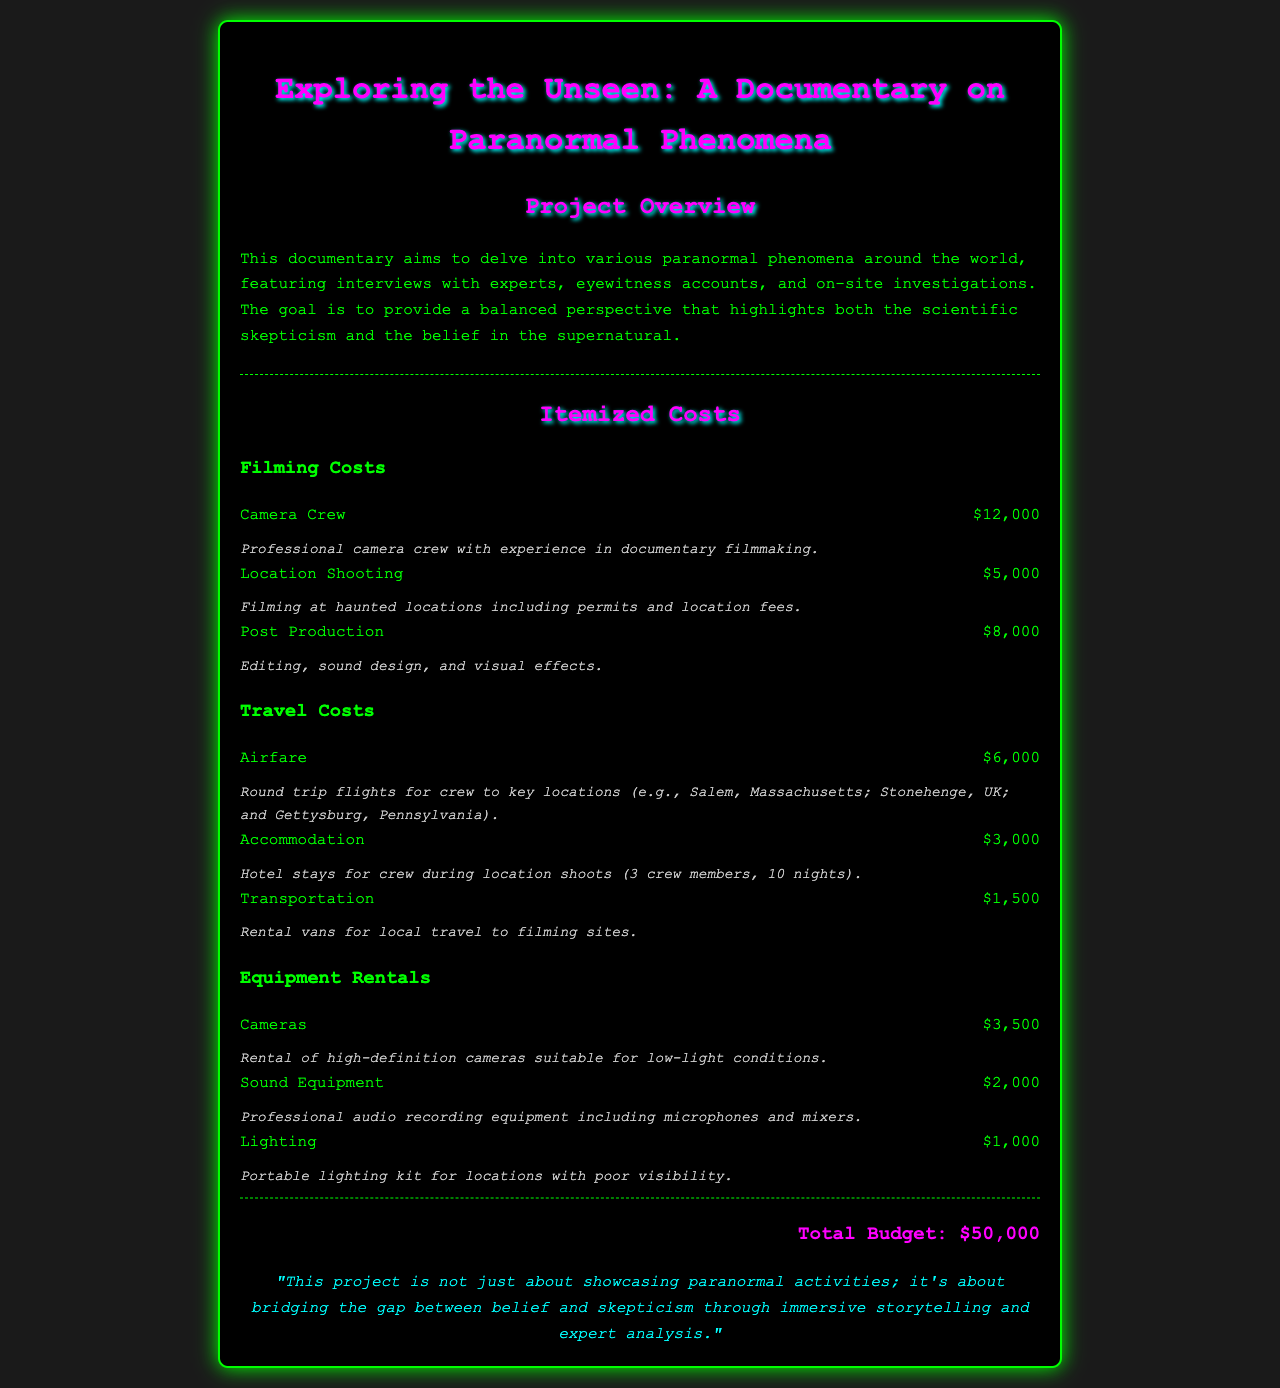What is the total budget? The total budget is explicitly stated at the end of the document.
Answer: $50,000 How much does the camera crew cost? The cost of the camera crew is listed as part of the filming costs.
Answer: $12,000 What locations are included for airfare? The document specifies key locations for crew travel, which can be identified in the travel costs section.
Answer: Salem, Massachusetts; Stonehenge, UK; Gettysburg, Pennsylvania What is the cost for sound equipment rental? The rental cost for sound equipment is detailed under the equipment rentals section.
Answer: $2,000 How many nights of accommodation are accounted for? The document mentions the number of nights for hotel stays during location shoots.
Answer: 10 nights What is the purpose of the documentary? The objective of the documentary is provided in the project overview section.
Answer: To delve into various paranormal phenomena What type of lighting is being rented? The type of lighting rental is described under equipment rentals.
Answer: Portable lighting kit Which item is the most expensive in the filming costs? The item with the highest cost in the filming section determines this answer.
Answer: Camera Crew What is mentioned as a justification for the project? A justification statement for the project’s aim can be found near the conclusion of the document.
Answer: Bridging the gap between belief and skepticism 